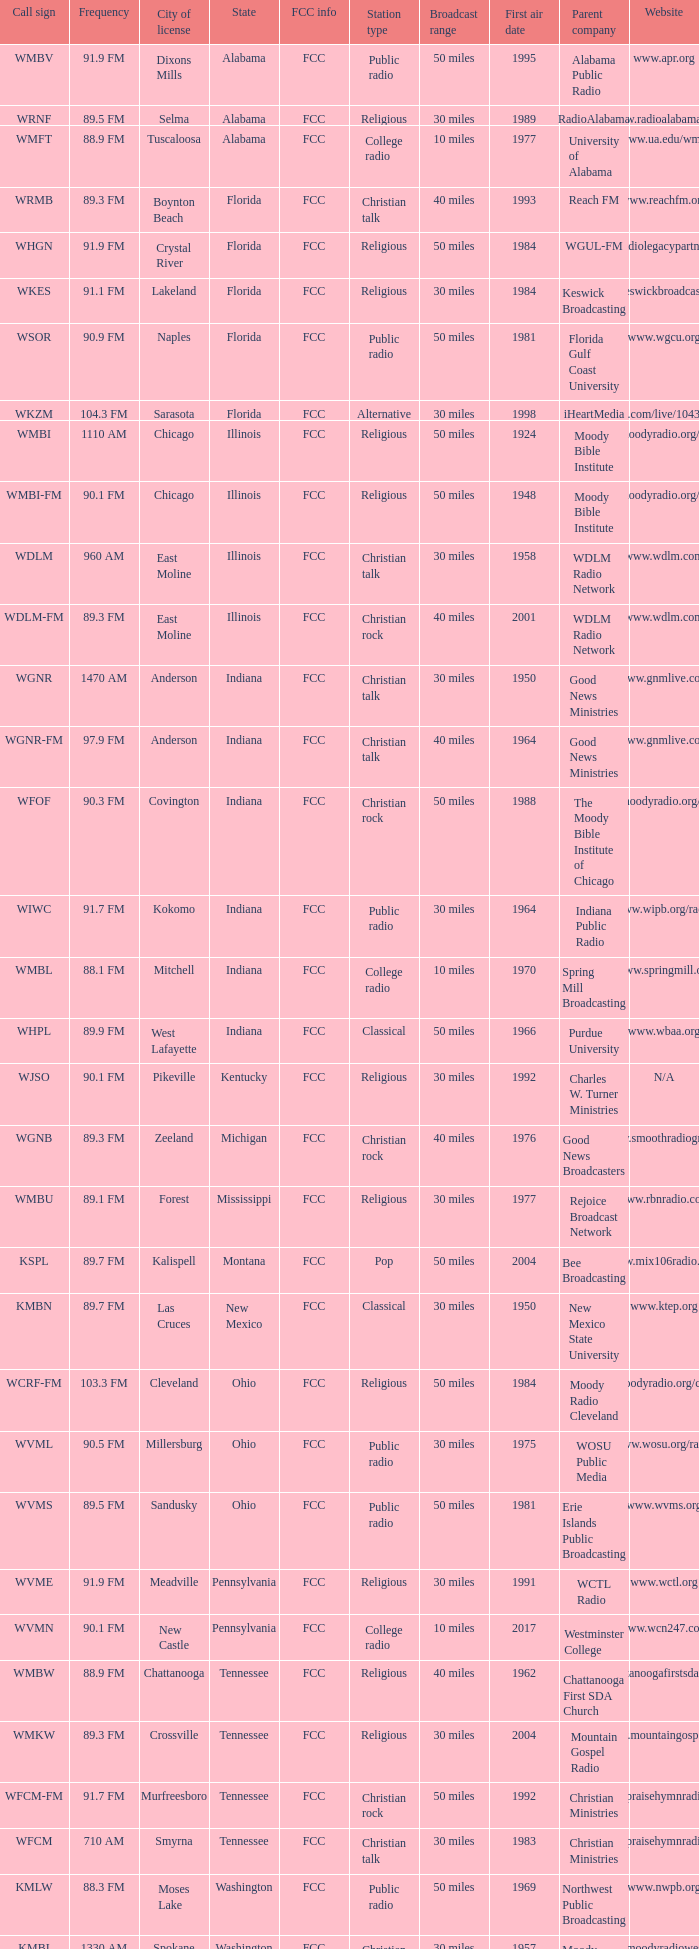What is the radio frequency of wgnr station located in indiana? 1470 AM. 